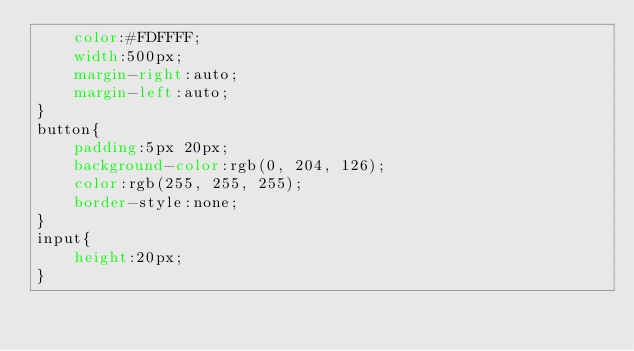<code> <loc_0><loc_0><loc_500><loc_500><_CSS_>    color:#FDFFFF;
    width:500px;
    margin-right:auto;
    margin-left:auto;
}
button{
    padding:5px 20px;
    background-color:rgb(0, 204, 126);
    color:rgb(255, 255, 255);
    border-style:none;
}
input{
    height:20px;
}
</code> 